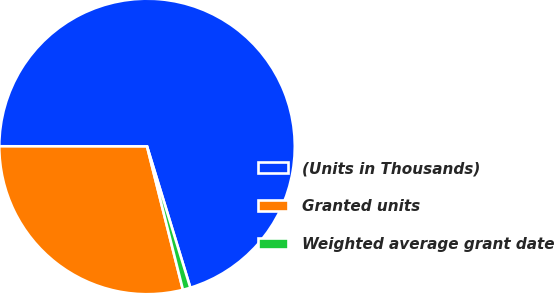<chart> <loc_0><loc_0><loc_500><loc_500><pie_chart><fcel>(Units in Thousands)<fcel>Granted units<fcel>Weighted average grant date<nl><fcel>70.25%<fcel>28.92%<fcel>0.83%<nl></chart> 